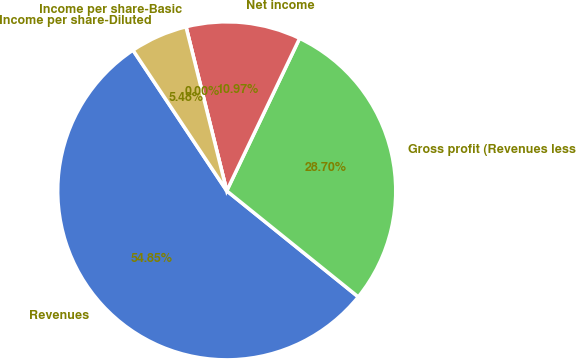Convert chart to OTSL. <chart><loc_0><loc_0><loc_500><loc_500><pie_chart><fcel>Revenues<fcel>Gross profit (Revenues less<fcel>Net income<fcel>Income per share-Basic<fcel>Income per share-Diluted<nl><fcel>54.84%<fcel>28.7%<fcel>10.97%<fcel>0.0%<fcel>5.48%<nl></chart> 